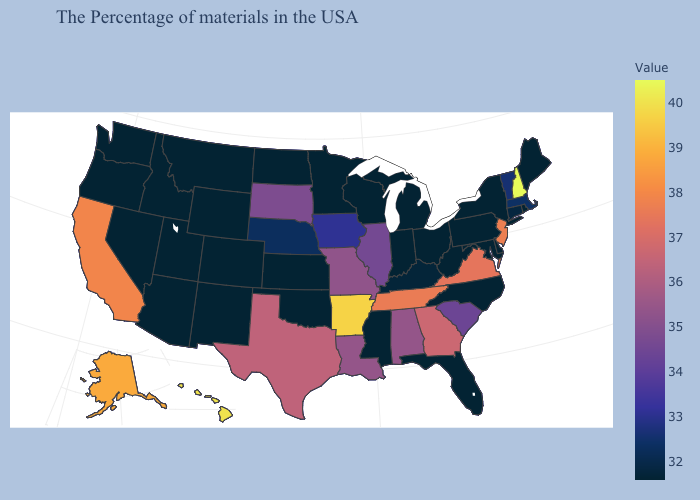Which states hav the highest value in the MidWest?
Give a very brief answer. Missouri. Which states have the lowest value in the Northeast?
Quick response, please. Maine, Rhode Island, New York, Pennsylvania. Among the states that border Vermont , does New Hampshire have the lowest value?
Keep it brief. No. Does New York have the lowest value in the USA?
Be succinct. Yes. 